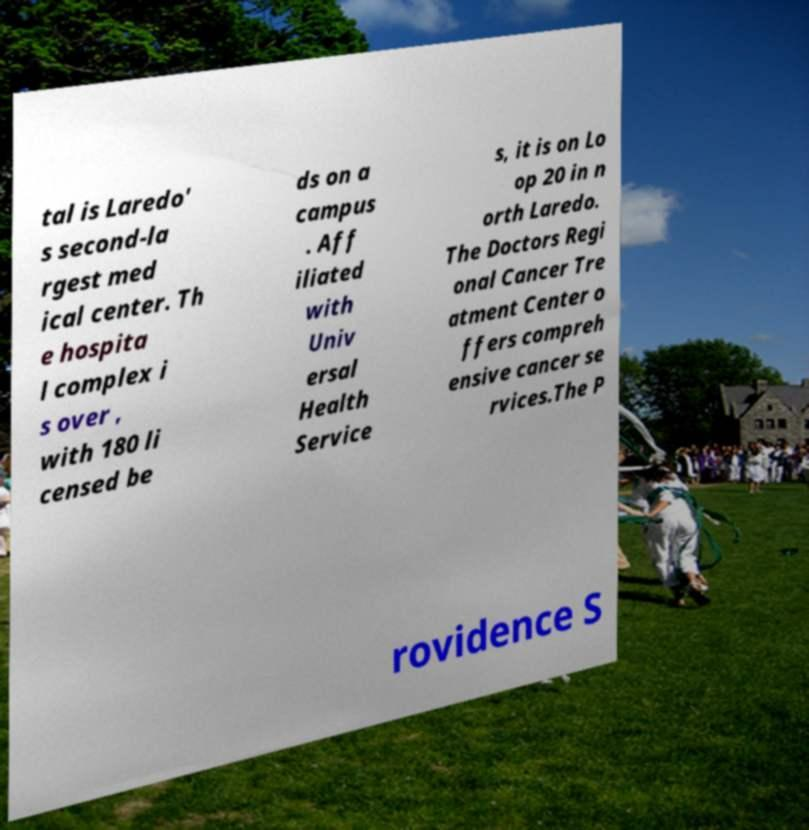For documentation purposes, I need the text within this image transcribed. Could you provide that? tal is Laredo' s second-la rgest med ical center. Th e hospita l complex i s over , with 180 li censed be ds on a campus . Aff iliated with Univ ersal Health Service s, it is on Lo op 20 in n orth Laredo. The Doctors Regi onal Cancer Tre atment Center o ffers compreh ensive cancer se rvices.The P rovidence S 